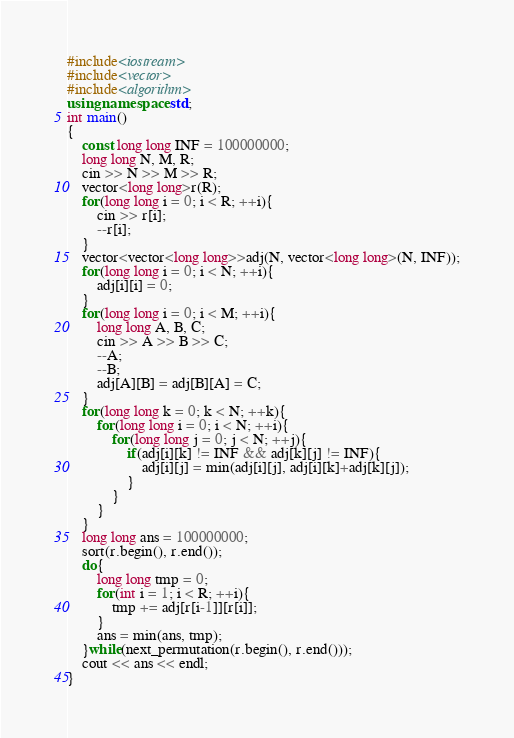<code> <loc_0><loc_0><loc_500><loc_500><_C++_>#include<iostream>
#include<vector>
#include<algorithm>
using namespace std;
int main()
{
    const long long INF = 100000000;
    long long N, M, R;
    cin >> N >> M >> R;
    vector<long long>r(R);
    for(long long i = 0; i < R; ++i){
        cin >> r[i];
        --r[i];
    }
    vector<vector<long long>>adj(N, vector<long long>(N, INF));
    for(long long i = 0; i < N; ++i){
        adj[i][i] = 0;
    }
    for(long long i = 0; i < M; ++i){
        long long A, B, C;
        cin >> A >> B >> C;
        --A;
        --B;
        adj[A][B] = adj[B][A] = C;
    }
    for(long long k = 0; k < N; ++k){
        for(long long i = 0; i < N; ++i){
            for(long long j = 0; j < N; ++j){
                if(adj[i][k] != INF && adj[k][j] != INF){
                    adj[i][j] = min(adj[i][j], adj[i][k]+adj[k][j]);
                }
            }
        }
    }
    long long ans = 100000000;
    sort(r.begin(), r.end());
    do{
        long long tmp = 0;
        for(int i = 1; i < R; ++i){
            tmp += adj[r[i-1]][r[i]];
        }
        ans = min(ans, tmp);
    }while(next_permutation(r.begin(), r.end()));
    cout << ans << endl;
}
</code> 